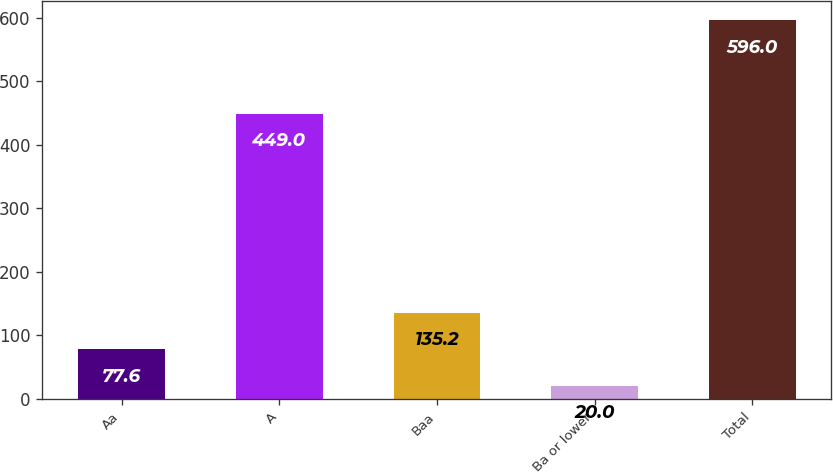<chart> <loc_0><loc_0><loc_500><loc_500><bar_chart><fcel>Aa<fcel>A<fcel>Baa<fcel>Ba or lower<fcel>Total<nl><fcel>77.6<fcel>449<fcel>135.2<fcel>20<fcel>596<nl></chart> 